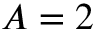Convert formula to latex. <formula><loc_0><loc_0><loc_500><loc_500>A = 2</formula> 